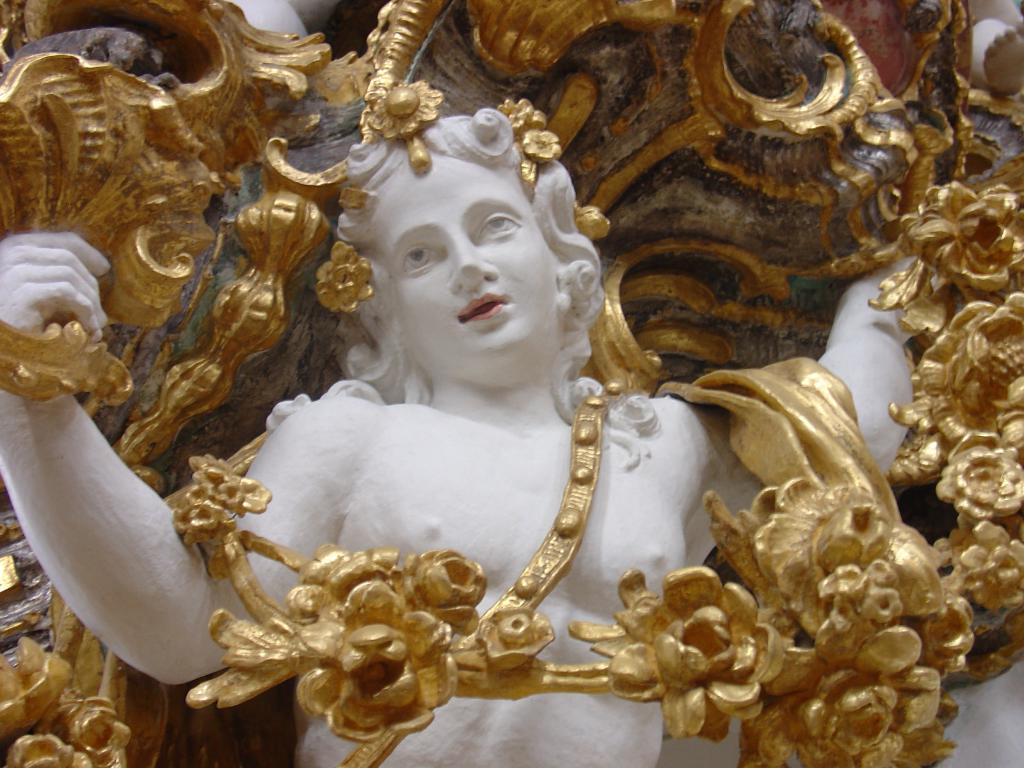What is the main subject of the image? The main subject of the image is a sculpture of a man. What is the color of the sculpture? The sculpture is in white color. What other details can be seen on the sculpture? There are carved flowers on the sculpture. What is the color of the carved flowers? The carved flowers are painted in golden color. Where is the nearest store to purchase authority in the image? There is no store or mention of authority in the image; it features a sculpture of a man with carved flowers. 